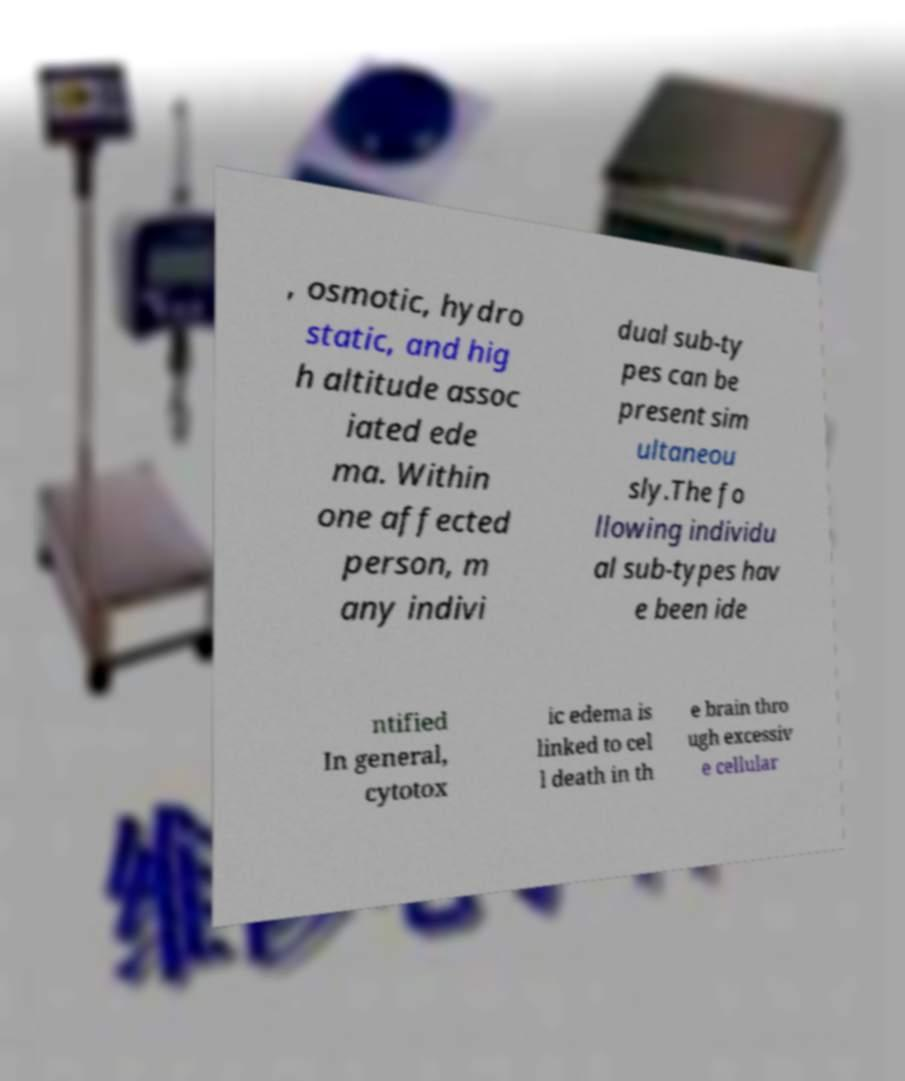For documentation purposes, I need the text within this image transcribed. Could you provide that? , osmotic, hydro static, and hig h altitude assoc iated ede ma. Within one affected person, m any indivi dual sub-ty pes can be present sim ultaneou sly.The fo llowing individu al sub-types hav e been ide ntified In general, cytotox ic edema is linked to cel l death in th e brain thro ugh excessiv e cellular 